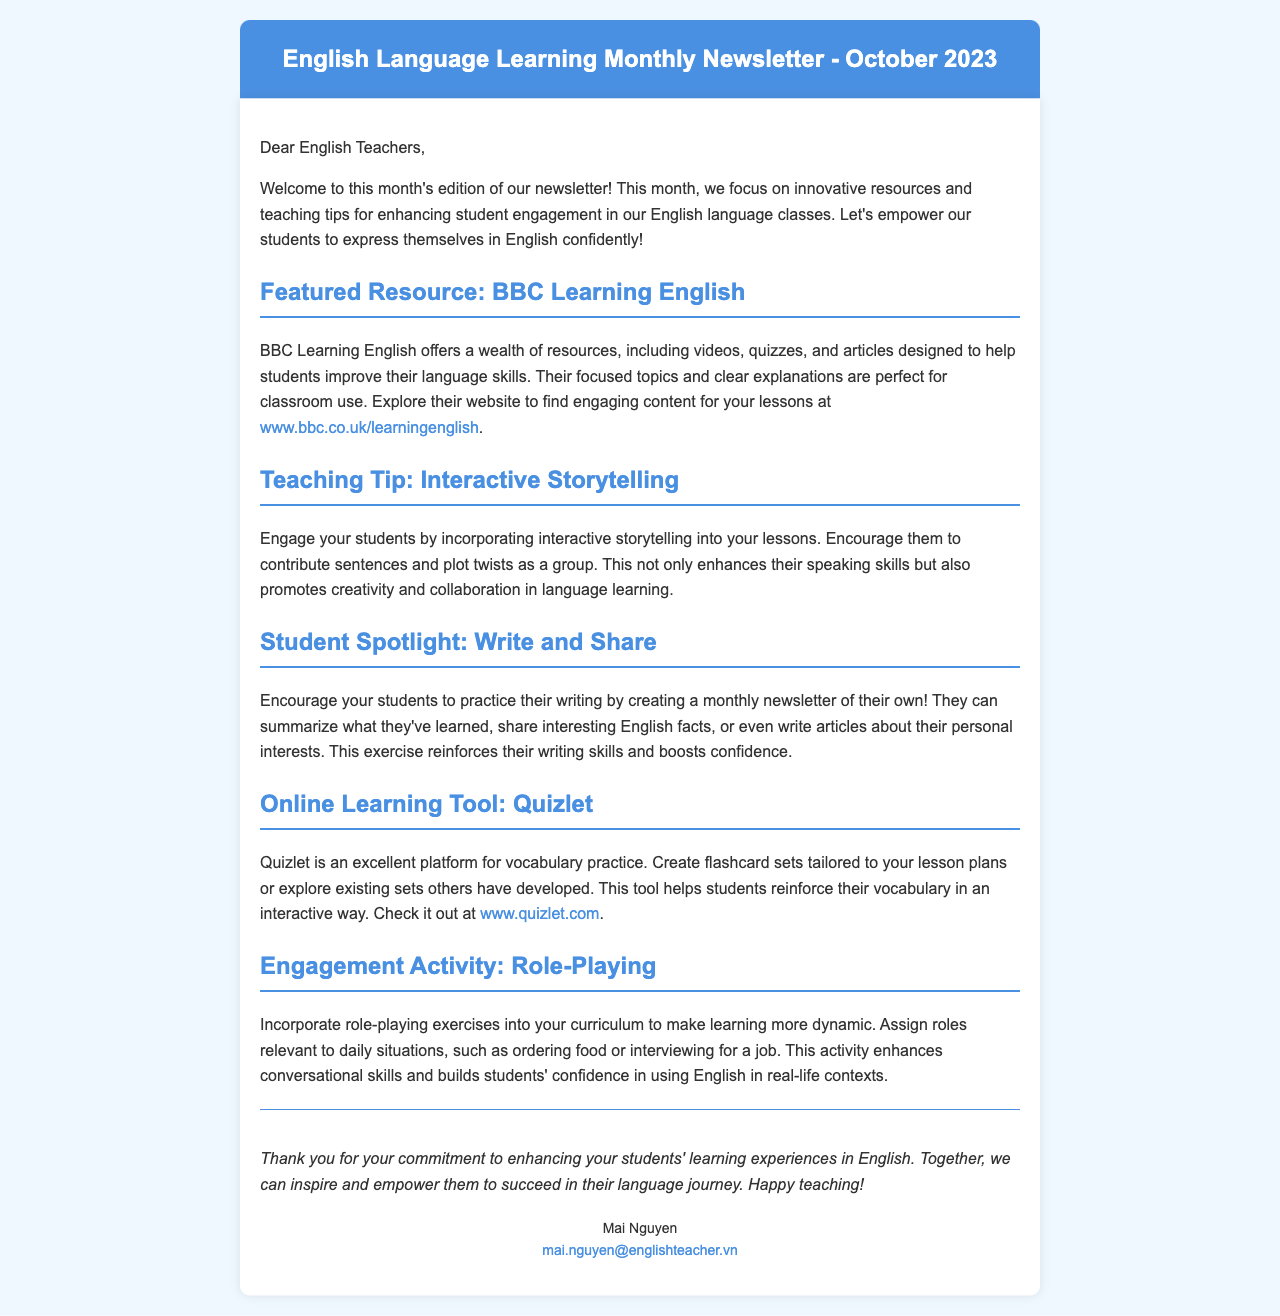What is the title of the newsletter? The title of the newsletter is prominently displayed at the top of the document.
Answer: English Language Learning Monthly Newsletter - October 2023 Who is the newsletter addressed to? The salutation at the beginning of the document indicates the intended audience.
Answer: English Teachers What is the featured resource mentioned in the newsletter? The newsletter specifies a particular resource in one of the sections.
Answer: BBC Learning English What interactive teaching tip is suggested in the newsletter? The newsletter includes a specific suggestion for engaging students in a section.
Answer: Interactive Storytelling What online learning tool is highlighted in the newsletter? The document explicitly mentions a tool in one of the sections.
Answer: Quizlet Which activity is proposed to enhance student engagement? The document suggests an engagement activity in one of the sections.
Answer: Role-Playing How can students contribute to a monthly newsletter of their own? The newsletter advises on a specific writing practice for students in one of the sections.
Answer: Write and Share What is the email address of the contact person? The contact information is given at the end of the document.
Answer: mai.nguyen@englishteacher.vn What is the primary focus of this month's newsletter? The opening paragraph summarizes the main theme of the newsletter.
Answer: Enhancing student engagement 